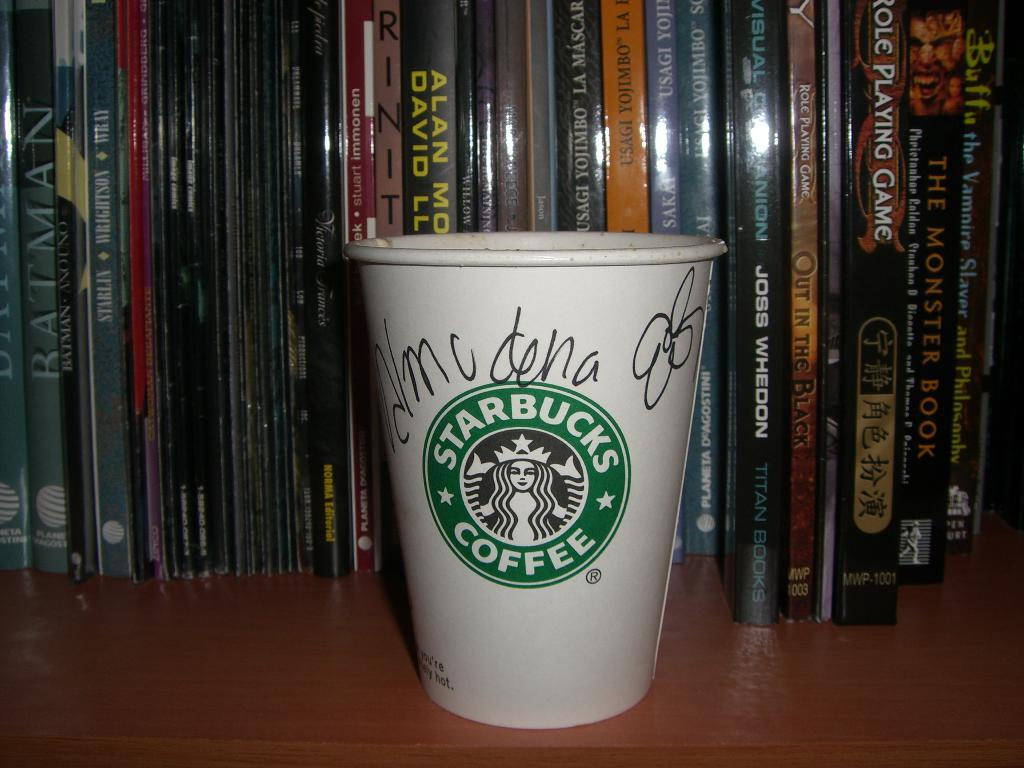Provide a one-sentence caption for the provided image. A coffee cup with a green label, in the label it says Starbucks. 